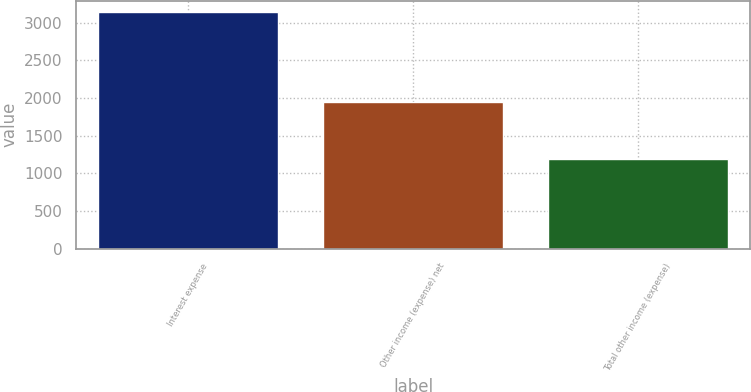<chart> <loc_0><loc_0><loc_500><loc_500><bar_chart><fcel>Interest expense<fcel>Other income (expense) net<fcel>Total other income (expense)<nl><fcel>3136<fcel>1952<fcel>1184<nl></chart> 